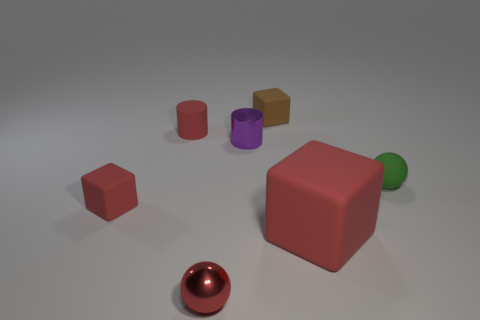Is the number of big gray cubes less than the number of cylinders?
Provide a short and direct response. Yes. There is a cube in front of the tiny red matte block; what size is it?
Make the answer very short. Large. What is the shape of the tiny object that is behind the green ball and left of the red shiny thing?
Make the answer very short. Cylinder. There is another thing that is the same shape as the green rubber thing; what is its size?
Your answer should be very brief. Small. What number of big red blocks have the same material as the green thing?
Your answer should be compact. 1. Is the color of the metal sphere the same as the small cylinder that is in front of the red rubber cylinder?
Offer a very short reply. No. Is the number of gray metal cylinders greater than the number of tiny brown things?
Your response must be concise. No. What color is the big object?
Your answer should be very brief. Red. Does the small metallic object that is in front of the tiny purple metallic cylinder have the same color as the metal cylinder?
Your answer should be very brief. No. There is a cylinder that is the same color as the large rubber block; what is its material?
Ensure brevity in your answer.  Rubber. 